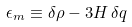Convert formula to latex. <formula><loc_0><loc_0><loc_500><loc_500>\epsilon _ { m } \equiv \delta \rho - 3 H \, \delta q</formula> 